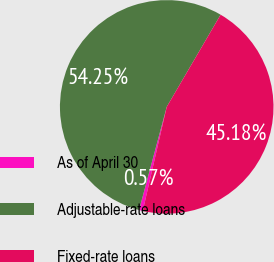<chart> <loc_0><loc_0><loc_500><loc_500><pie_chart><fcel>As of April 30<fcel>Adjustable-rate loans<fcel>Fixed-rate loans<nl><fcel>0.57%<fcel>54.25%<fcel>45.18%<nl></chart> 